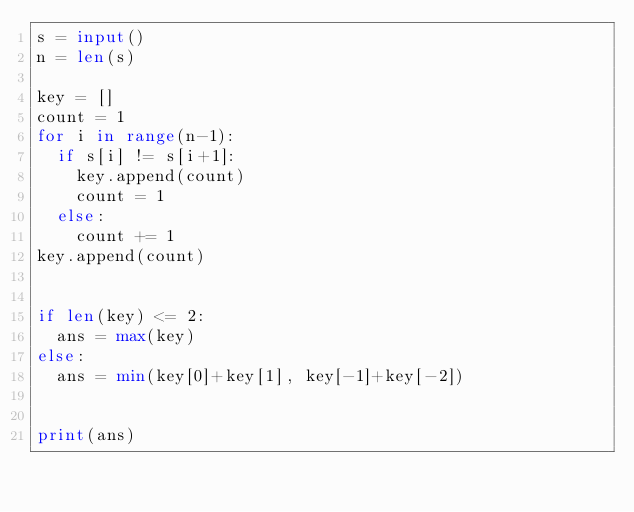<code> <loc_0><loc_0><loc_500><loc_500><_Python_>s = input()
n = len(s)

key = []
count = 1
for i in range(n-1):
  if s[i] != s[i+1]:
    key.append(count)
    count = 1
  else:
    count += 1
key.append(count)


if len(key) <= 2:
  ans = max(key)
else:
  ans = min(key[0]+key[1], key[-1]+key[-2])
  

print(ans)</code> 